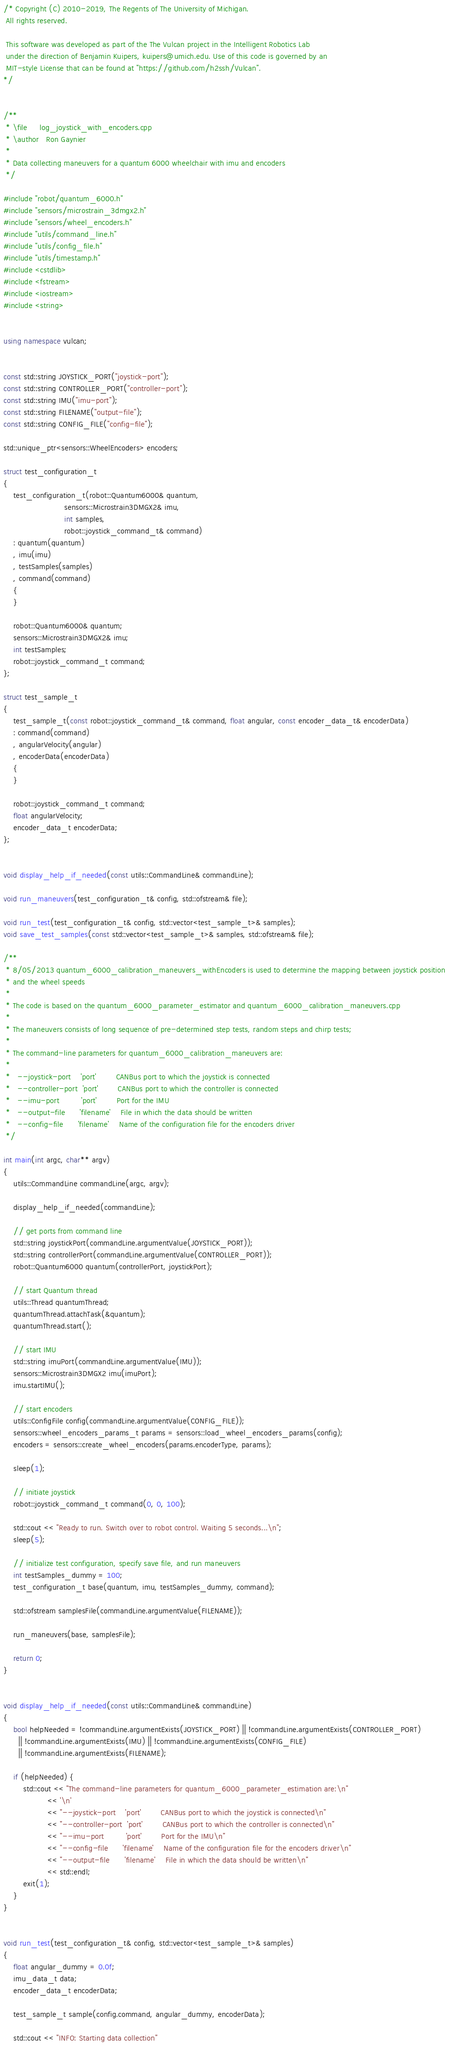<code> <loc_0><loc_0><loc_500><loc_500><_C++_>/* Copyright (C) 2010-2019, The Regents of The University of Michigan.
 All rights reserved.

 This software was developed as part of the The Vulcan project in the Intelligent Robotics Lab
 under the direction of Benjamin Kuipers, kuipers@umich.edu. Use of this code is governed by an
 MIT-style License that can be found at "https://github.com/h2ssh/Vulcan".
*/


/**
 * \file     log_joystick_with_encoders.cpp
 * \author   Ron Gaynier
 *
 * Data collecting maneuvers for a quantum 6000 wheelchair with imu and encoders
 */

#include "robot/quantum_6000.h"
#include "sensors/microstrain_3dmgx2.h"
#include "sensors/wheel_encoders.h"
#include "utils/command_line.h"
#include "utils/config_file.h"
#include "utils/timestamp.h"
#include <cstdlib>
#include <fstream>
#include <iostream>
#include <string>


using namespace vulcan;


const std::string JOYSTICK_PORT("joystick-port");
const std::string CONTROLLER_PORT("controller-port");
const std::string IMU("imu-port");
const std::string FILENAME("output-file");
const std::string CONFIG_FILE("config-file");

std::unique_ptr<sensors::WheelEncoders> encoders;

struct test_configuration_t
{
    test_configuration_t(robot::Quantum6000& quantum,
                         sensors::Microstrain3DMGX2& imu,
                         int samples,
                         robot::joystick_command_t& command)
    : quantum(quantum)
    , imu(imu)
    , testSamples(samples)
    , command(command)
    {
    }

    robot::Quantum6000& quantum;
    sensors::Microstrain3DMGX2& imu;
    int testSamples;
    robot::joystick_command_t command;
};

struct test_sample_t
{
    test_sample_t(const robot::joystick_command_t& command, float angular, const encoder_data_t& encoderData)
    : command(command)
    , angularVelocity(angular)
    , encoderData(encoderData)
    {
    }

    robot::joystick_command_t command;
    float angularVelocity;
    encoder_data_t encoderData;
};


void display_help_if_needed(const utils::CommandLine& commandLine);

void run_maneuvers(test_configuration_t& config, std::ofstream& file);

void run_test(test_configuration_t& config, std::vector<test_sample_t>& samples);
void save_test_samples(const std::vector<test_sample_t>& samples, std::ofstream& file);

/**
 * 8/05/2013 quantum_6000_calibration_maneuvers_withEncoders is used to determine the mapping between joystick position
 * and the wheel speeds
 *
 * The code is based on the quantum_6000_parameter_estimator and quantum_6000_calibration_maneuvers.cpp
 *
 * The maneuvers consists of long sequence of pre-determined step tests, random steps and chirp tests;
 *
 * The command-line parameters for quantum_6000_calibration_maneuvers are:
 *
 *   --joystick-port    'port'        CANBus port to which the joystick is connected
 *   --controller-port  'port'        CANBus port to which the controller is connected
 *   --imu-port         'port'        Port for the IMU
 *   --output-file      'filename'    File in which the data should be written
 *   --config-file      'filename'    Name of the configuration file for the encoders driver
 */

int main(int argc, char** argv)
{
    utils::CommandLine commandLine(argc, argv);

    display_help_if_needed(commandLine);

    // get ports from command line
    std::string joystickPort(commandLine.argumentValue(JOYSTICK_PORT));
    std::string controllerPort(commandLine.argumentValue(CONTROLLER_PORT));
    robot::Quantum6000 quantum(controllerPort, joystickPort);

    // start Quantum thread
    utils::Thread quantumThread;
    quantumThread.attachTask(&quantum);
    quantumThread.start();

    // start IMU
    std::string imuPort(commandLine.argumentValue(IMU));
    sensors::Microstrain3DMGX2 imu(imuPort);
    imu.startIMU();

    // start encoders
    utils::ConfigFile config(commandLine.argumentValue(CONFIG_FILE));
    sensors::wheel_encoders_params_t params = sensors::load_wheel_encoders_params(config);
    encoders = sensors::create_wheel_encoders(params.encoderType, params);

    sleep(1);

    // initiate joystick
    robot::joystick_command_t command(0, 0, 100);

    std::cout << "Ready to run. Switch over to robot control. Waiting 5 seconds...\n";
    sleep(5);

    // initialize test configuration, specify save file, and run maneuvers
    int testSamples_dummy = 100;
    test_configuration_t base(quantum, imu, testSamples_dummy, command);

    std::ofstream samplesFile(commandLine.argumentValue(FILENAME));

    run_maneuvers(base, samplesFile);

    return 0;
}


void display_help_if_needed(const utils::CommandLine& commandLine)
{
    bool helpNeeded = !commandLine.argumentExists(JOYSTICK_PORT) || !commandLine.argumentExists(CONTROLLER_PORT)
      || !commandLine.argumentExists(IMU) || !commandLine.argumentExists(CONFIG_FILE)
      || !commandLine.argumentExists(FILENAME);

    if (helpNeeded) {
        std::cout << "The command-line parameters for quantum_6000_parameter_estimation are:\n"
                  << '\n'
                  << "--joystick-port    'port'        CANBus port to which the joystick is connected\n"
                  << "--controller-port  'port'        CANBus port to which the controller is connected\n"
                  << "--imu-port         'port'        Port for the IMU\n"
                  << "--config-file      'filename'    Name of the configuration file for the encoders driver\n"
                  << "--output-file      'filename'    File in which the data should be written\n"
                  << std::endl;
        exit(1);
    }
}


void run_test(test_configuration_t& config, std::vector<test_sample_t>& samples)
{
    float angular_dummy = 0.0f;
    imu_data_t data;
    encoder_data_t encoderData;

    test_sample_t sample(config.command, angular_dummy, encoderData);

    std::cout << "INFO: Starting data collection"</code> 